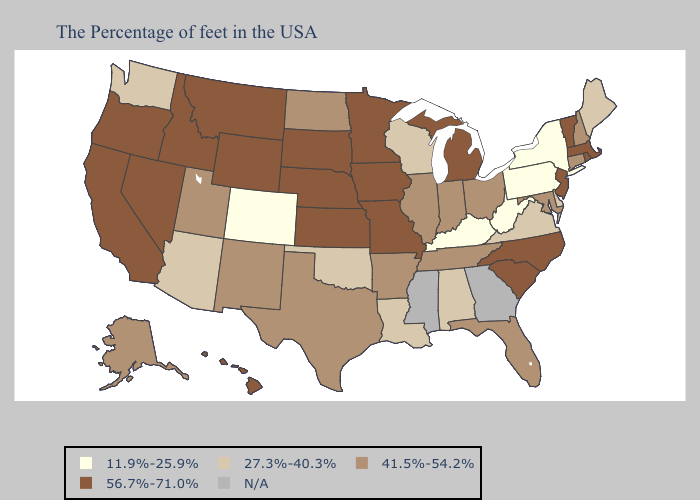Name the states that have a value in the range N/A?
Concise answer only. Georgia, Mississippi. Does New York have the highest value in the Northeast?
Be succinct. No. Among the states that border California , which have the highest value?
Keep it brief. Nevada, Oregon. Does Washington have the lowest value in the USA?
Be succinct. No. What is the highest value in the USA?
Short answer required. 56.7%-71.0%. What is the lowest value in the MidWest?
Answer briefly. 27.3%-40.3%. Name the states that have a value in the range 41.5%-54.2%?
Write a very short answer. New Hampshire, Connecticut, Maryland, Ohio, Florida, Indiana, Tennessee, Illinois, Arkansas, Texas, North Dakota, New Mexico, Utah, Alaska. Name the states that have a value in the range 27.3%-40.3%?
Give a very brief answer. Maine, Delaware, Virginia, Alabama, Wisconsin, Louisiana, Oklahoma, Arizona, Washington. What is the value of Nevada?
Answer briefly. 56.7%-71.0%. How many symbols are there in the legend?
Answer briefly. 5. Does Oregon have the highest value in the West?
Short answer required. Yes. Does Kentucky have the highest value in the USA?
Quick response, please. No. What is the lowest value in the South?
Write a very short answer. 11.9%-25.9%. Among the states that border Montana , which have the lowest value?
Write a very short answer. North Dakota. 